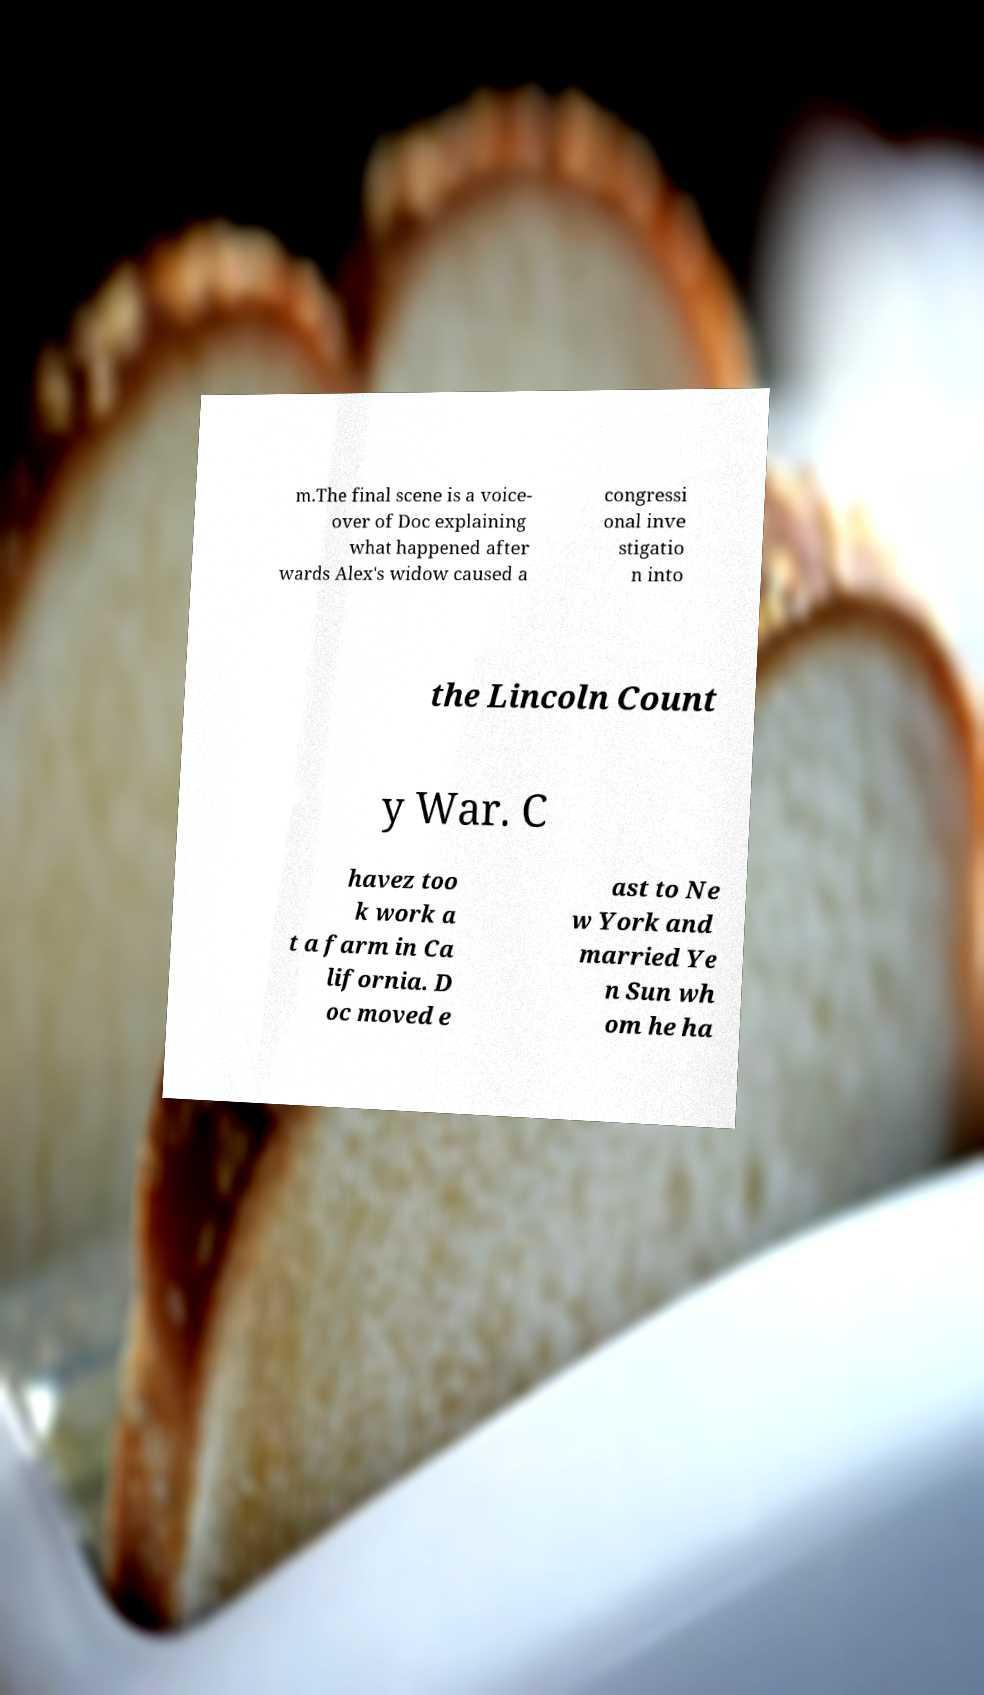Can you accurately transcribe the text from the provided image for me? m.The final scene is a voice- over of Doc explaining what happened after wards Alex's widow caused a congressi onal inve stigatio n into the Lincoln Count y War. C havez too k work a t a farm in Ca lifornia. D oc moved e ast to Ne w York and married Ye n Sun wh om he ha 